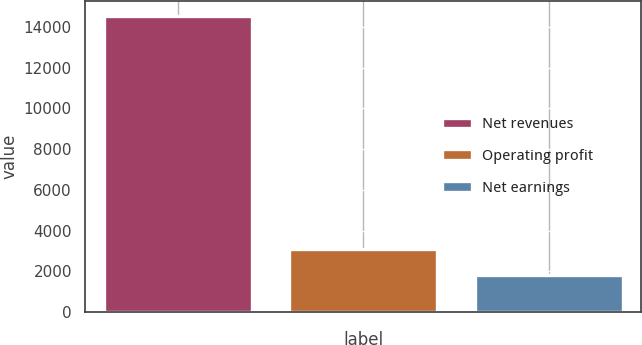Convert chart. <chart><loc_0><loc_0><loc_500><loc_500><bar_chart><fcel>Net revenues<fcel>Operating profit<fcel>Net earnings<nl><fcel>14543<fcel>3077<fcel>1803<nl></chart> 